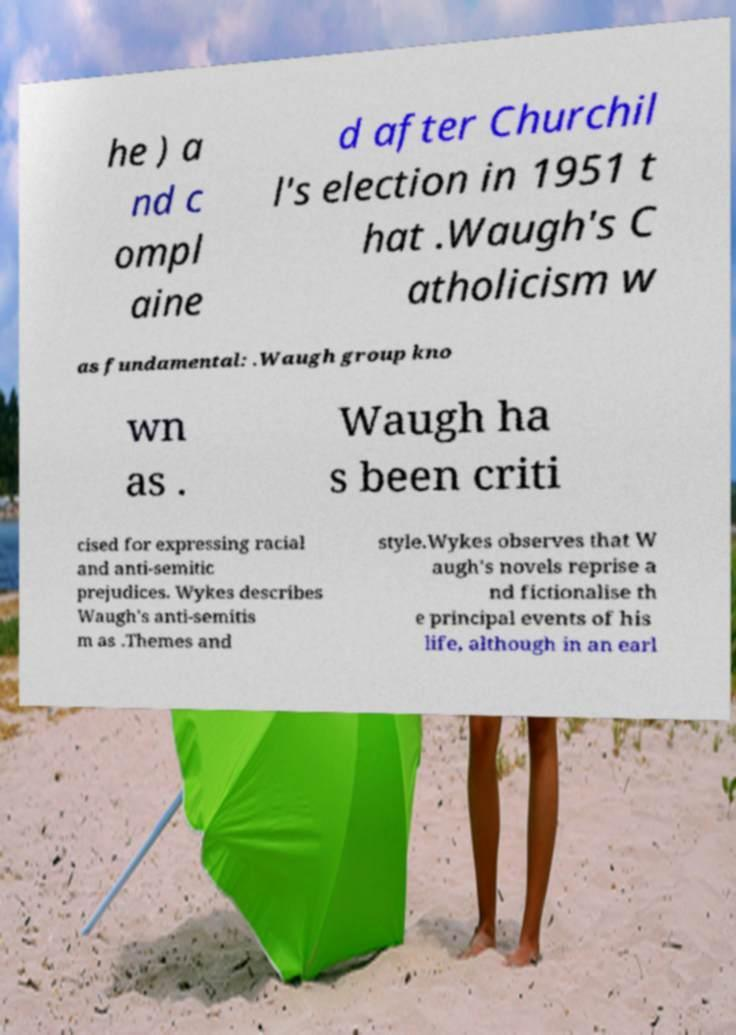For documentation purposes, I need the text within this image transcribed. Could you provide that? he ) a nd c ompl aine d after Churchil l's election in 1951 t hat .Waugh's C atholicism w as fundamental: .Waugh group kno wn as . Waugh ha s been criti cised for expressing racial and anti-semitic prejudices. Wykes describes Waugh's anti-semitis m as .Themes and style.Wykes observes that W augh's novels reprise a nd fictionalise th e principal events of his life, although in an earl 